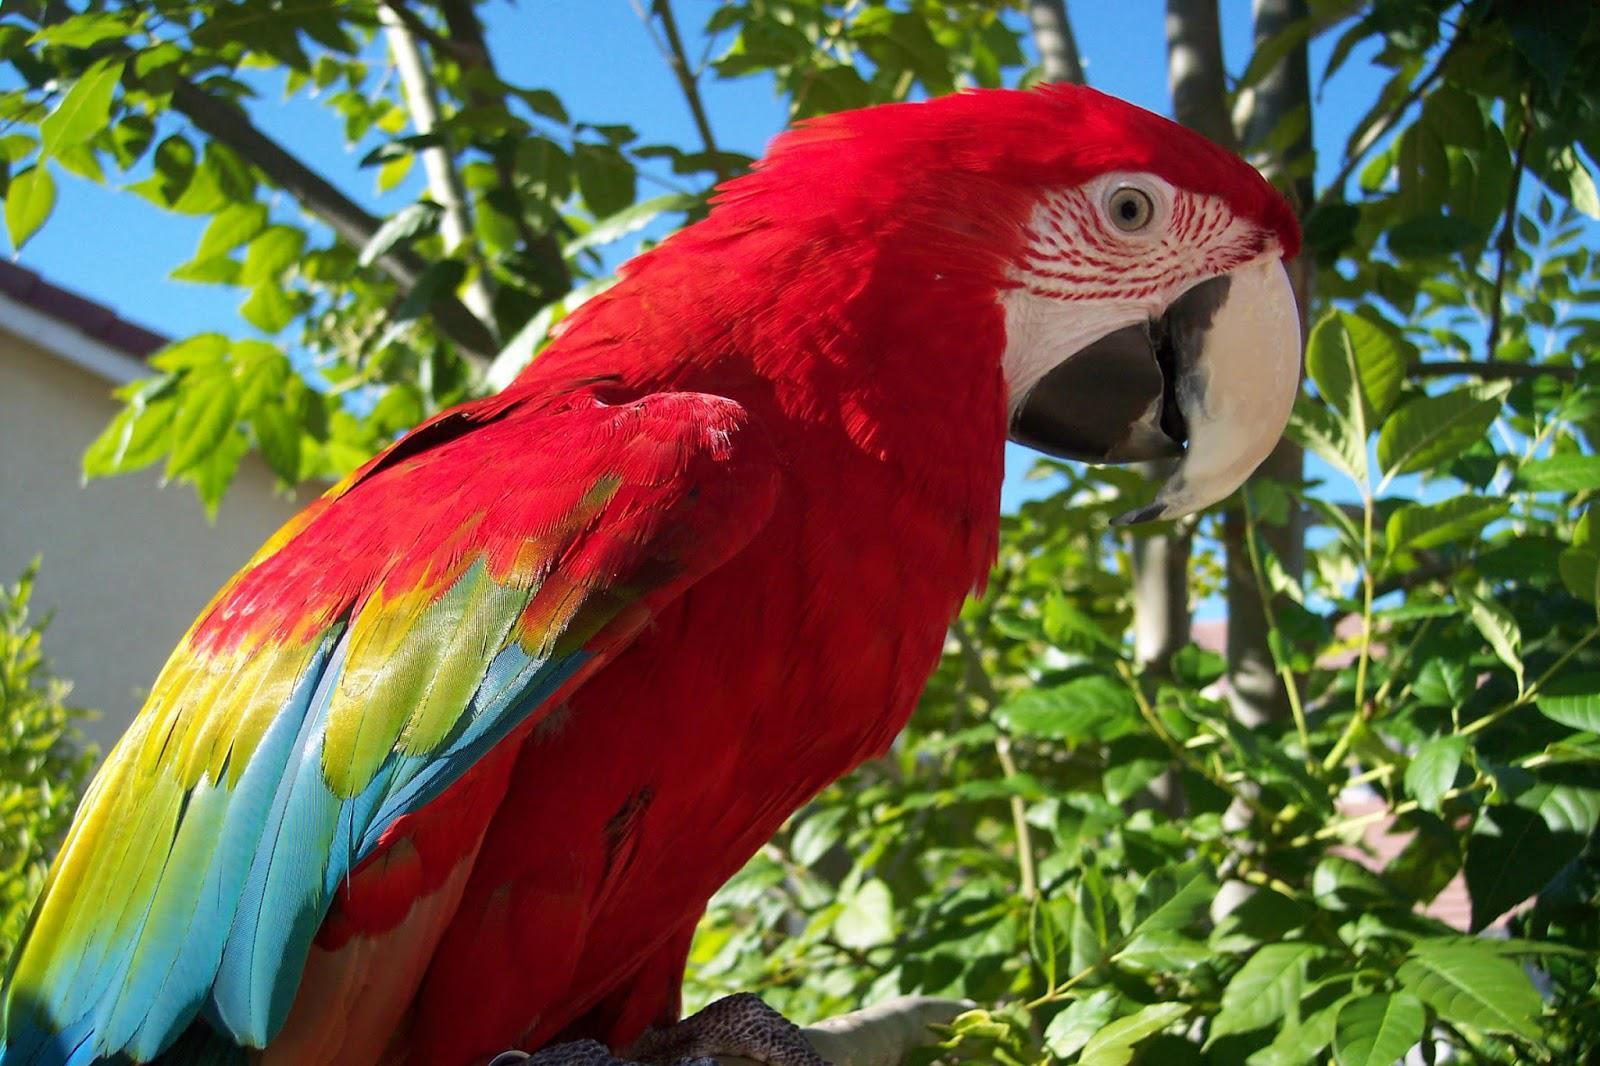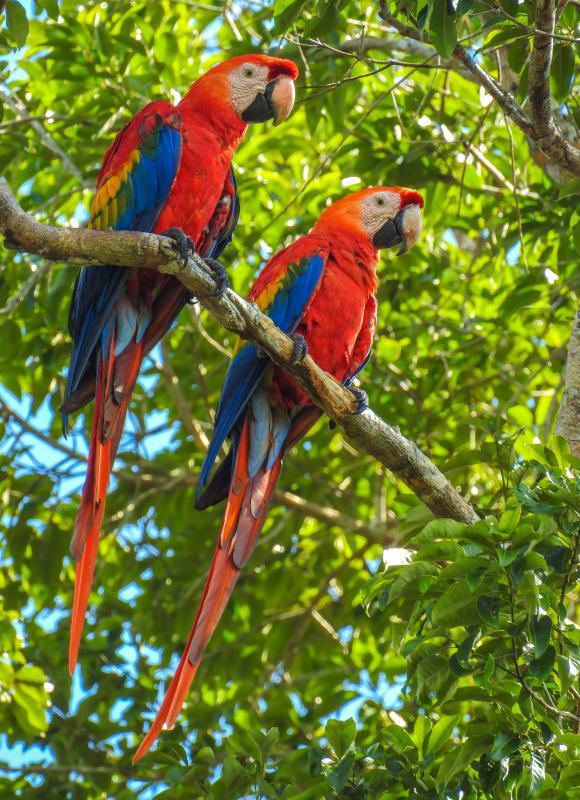The first image is the image on the left, the second image is the image on the right. Assess this claim about the two images: "Two birds are perched together in one of the images.". Correct or not? Answer yes or no. Yes. 